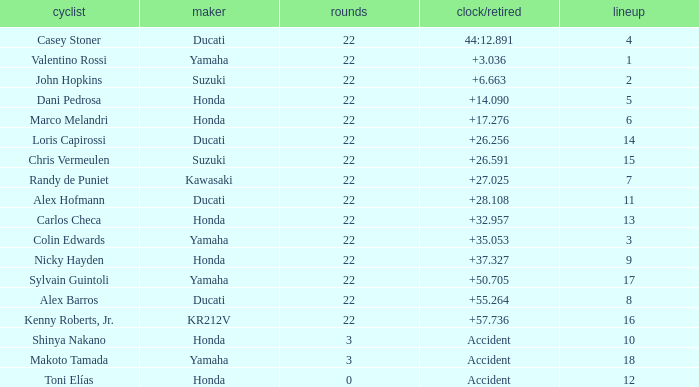What is the average grid for the competitiors who had laps smaller than 3? 12.0. 